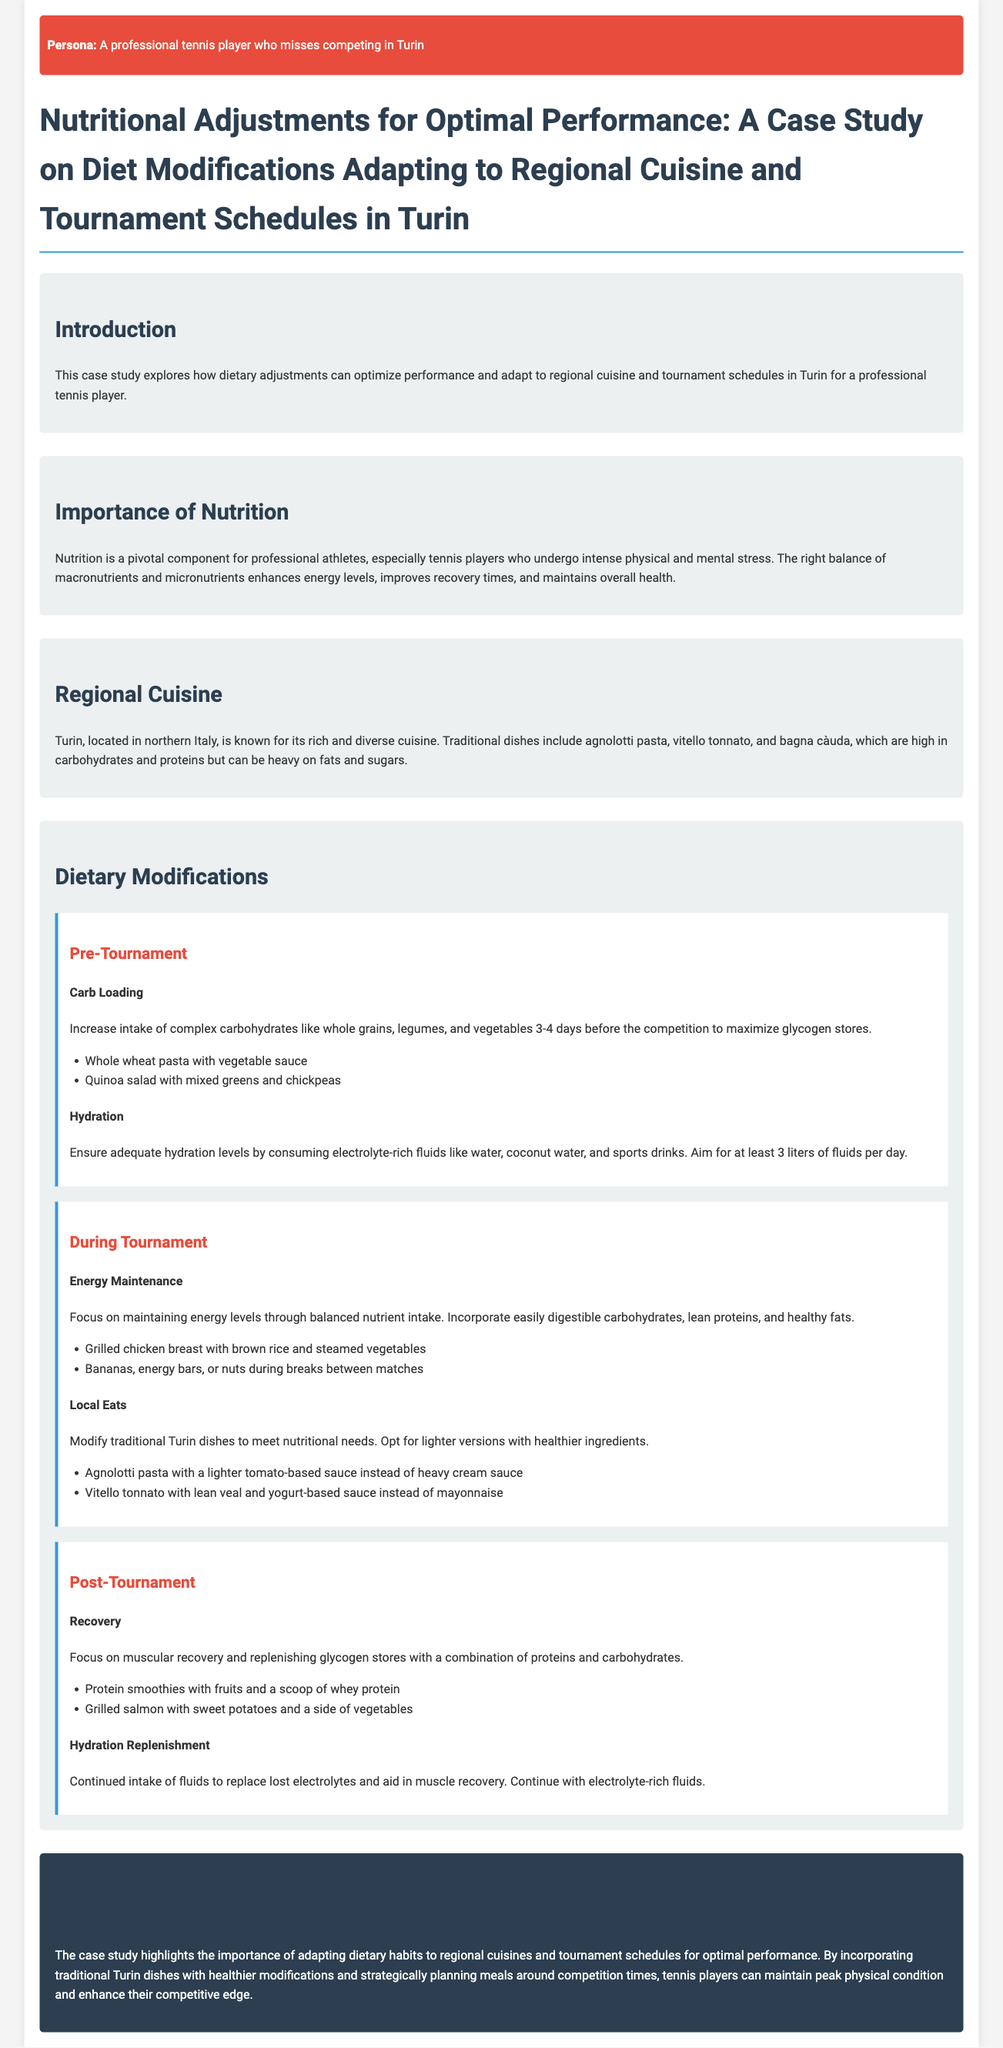What is the main focus of the case study? The main focus of the case study is on dietary adjustments for optimal performance, specifically adapting to regional cuisine and tournament schedules in Turin.
Answer: dietary adjustments for optimal performance What are two traditional dishes mentioned in the document? The document mentions traditional dishes such as agnolotti pasta and vitello tonnato.
Answer: agnolotti pasta, vitello tonnato How many liters of fluids should be consumed per day for hydration? The document states that athletes should aim for at least 3 liters of fluids per day for hydration.
Answer: 3 liters What is one food recommended for energy maintenance during the tournament? The document lists grilled chicken breast with brown rice and steamed vegetables as a food recommended for energy maintenance during the tournament.
Answer: grilled chicken breast with brown rice and steamed vegetables What type of cuisine is Turin known for? Turin is known for its rich and diverse cuisine.
Answer: rich and diverse cuisine What is the goal of carb loading before a tournament? The goal of carb loading is to maximize glycogen stores prior to competition.
Answer: maximize glycogen stores What is a suggested post-tournament recovery food? The document suggests having protein smoothies with fruits and a scoop of whey protein for post-tournament recovery.
Answer: protein smoothies with fruits and a scoop of whey protein What is emphasized as important for muscular recovery? The document emphasizes the importance of replenishing glycogen stores for muscular recovery.
Answer: replenishing glycogen stores 